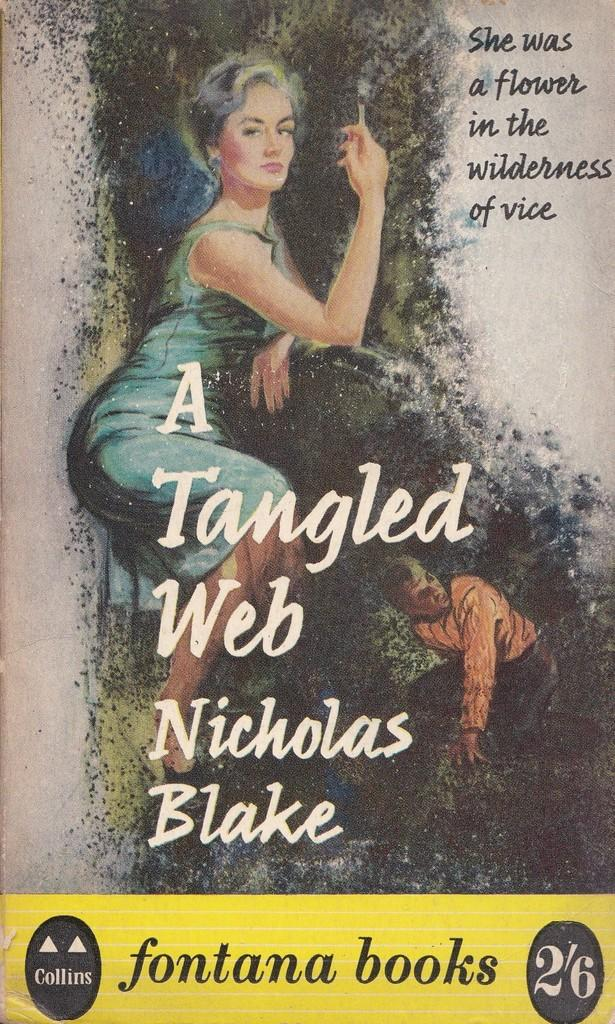<image>
Give a short and clear explanation of the subsequent image. a book that is called A Tangled Web with a photo on it 